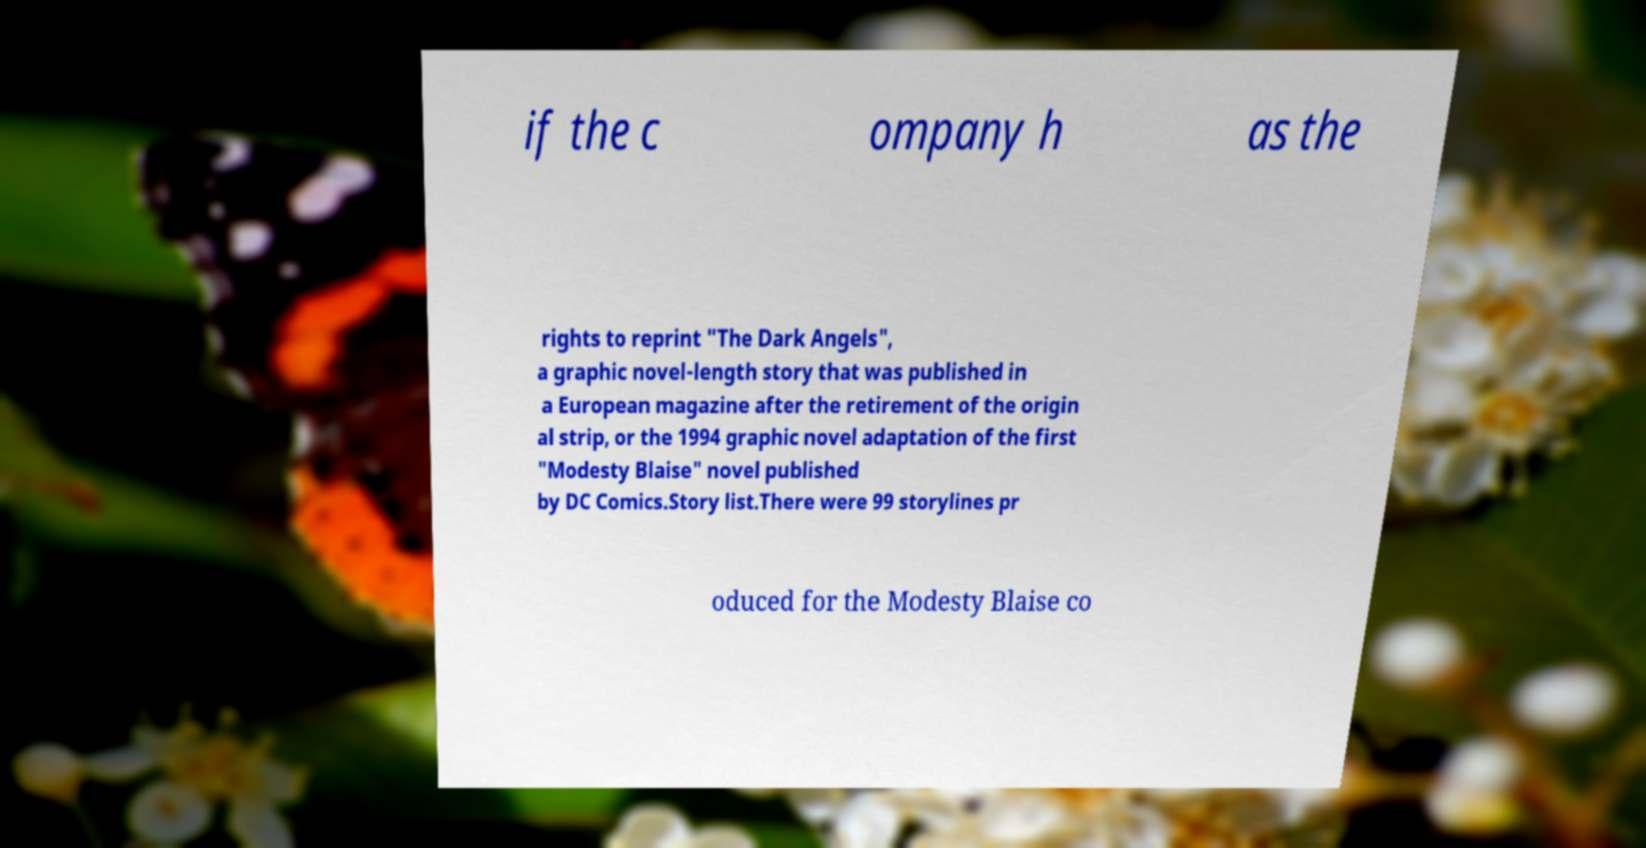Can you accurately transcribe the text from the provided image for me? if the c ompany h as the rights to reprint "The Dark Angels", a graphic novel-length story that was published in a European magazine after the retirement of the origin al strip, or the 1994 graphic novel adaptation of the first "Modesty Blaise" novel published by DC Comics.Story list.There were 99 storylines pr oduced for the Modesty Blaise co 